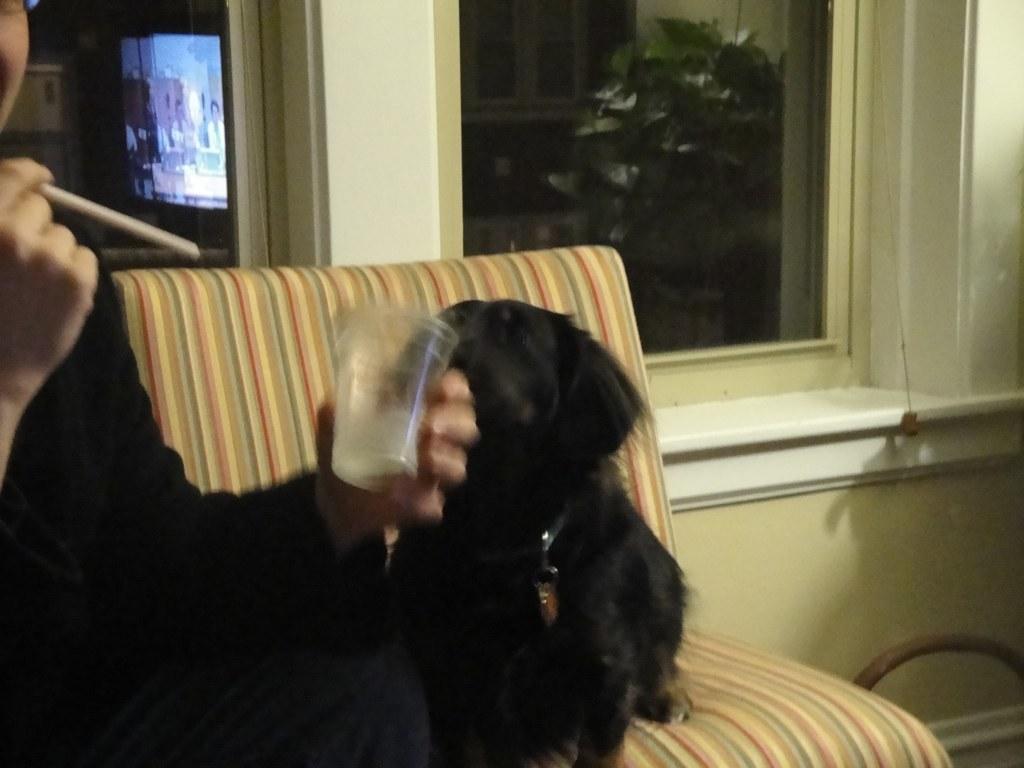Can you describe this image briefly? In this picture we can see a person holding a straw in one hand and a cup in another hand. There is a black dog which is sitting on a sofa. A screen is visible at the back. We can see a plant and a building in the background. 